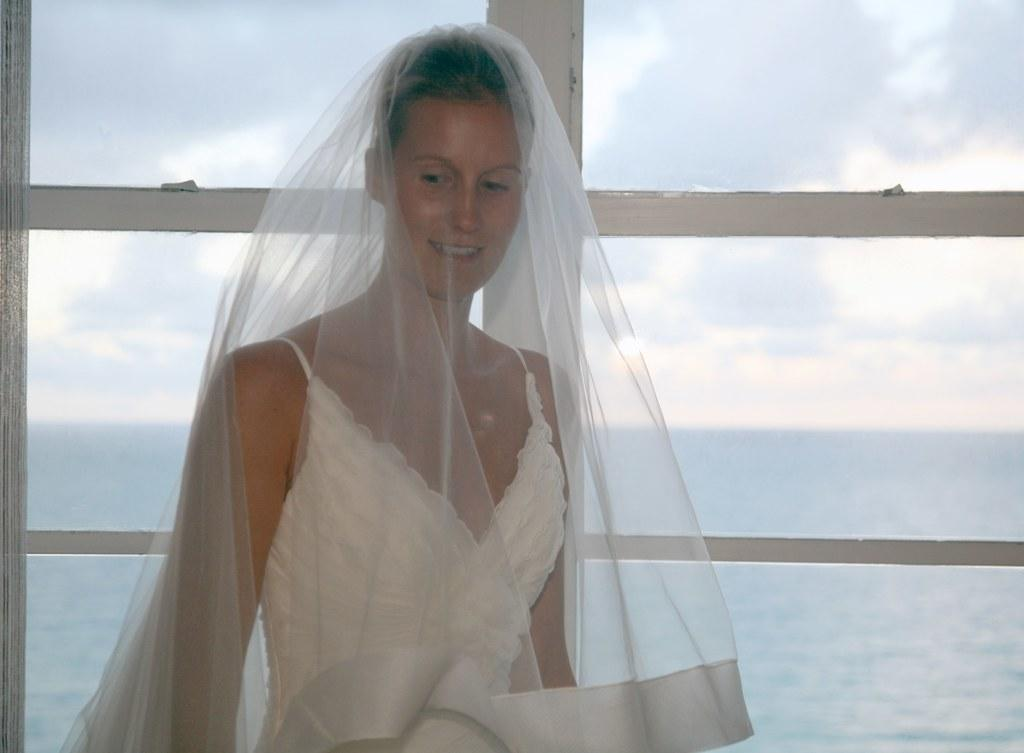Who is present in the image? There is a woman in the image. What is the woman wearing? The woman is wearing a white dress. What is the woman doing in the image? The woman is standing and smiling. What can be seen in the background of the image? There is a window in the background of the image, with water and the sky visible through it. Where is the throne located in the image? There is no throne present in the image. What type of ear is visible on the woman in the image? The woman's ears are not visible in the image, so it cannot be determined what type of ear she has. 